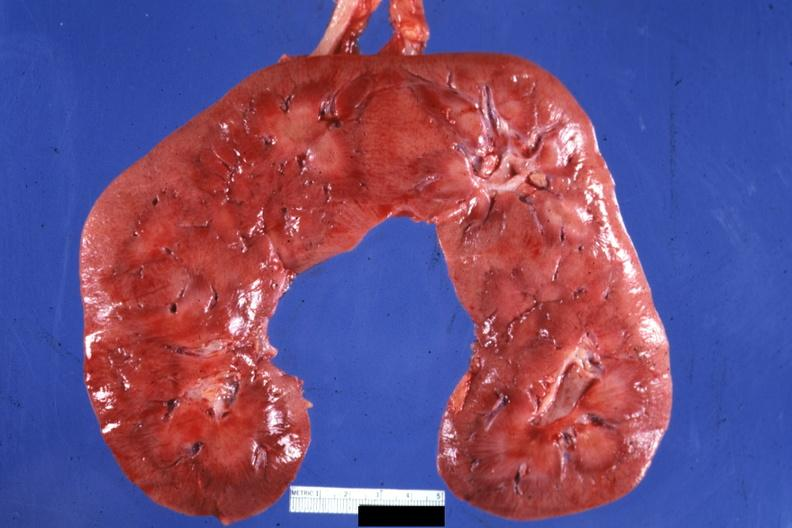does this image show frontal section quite good?
Answer the question using a single word or phrase. Yes 